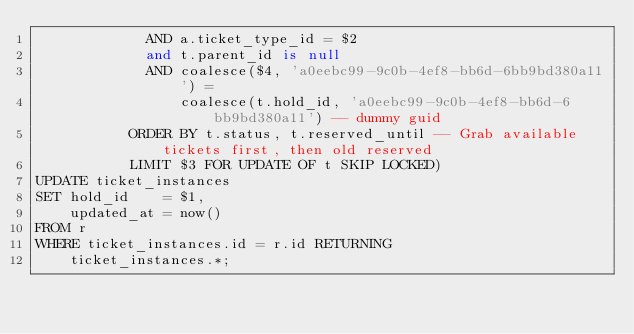<code> <loc_0><loc_0><loc_500><loc_500><_SQL_>             AND a.ticket_type_id = $2
             and t.parent_id is null
             AND coalesce($4, 'a0eebc99-9c0b-4ef8-bb6d-6bb9bd380a11') =
                 coalesce(t.hold_id, 'a0eebc99-9c0b-4ef8-bb6d-6bb9bd380a11') -- dummy guid
           ORDER BY t.status, t.reserved_until -- Grab available tickets first, then old reserved
           LIMIT $3 FOR UPDATE OF t SKIP LOCKED)
UPDATE ticket_instances
SET hold_id    = $1,
    updated_at = now()
FROM r
WHERE ticket_instances.id = r.id RETURNING
    ticket_instances.*;

</code> 